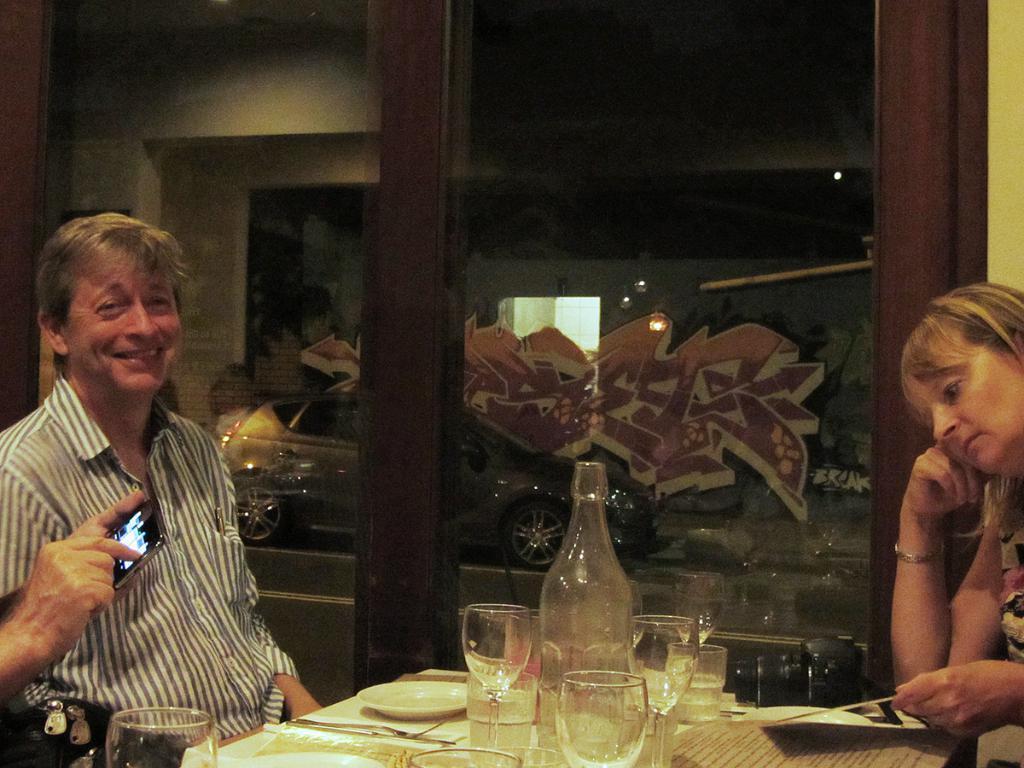Please provide a concise description of this image. This picture is taken in a restaurant where there are persons sitting. The man at the left side is having smile on his face. In the center on the table there are glass, bottle, plant, tissues. At the right side woman is leaning on the table and is holding a book in her hand. In the background there is a glass door and a reflection of the car on the glass. 